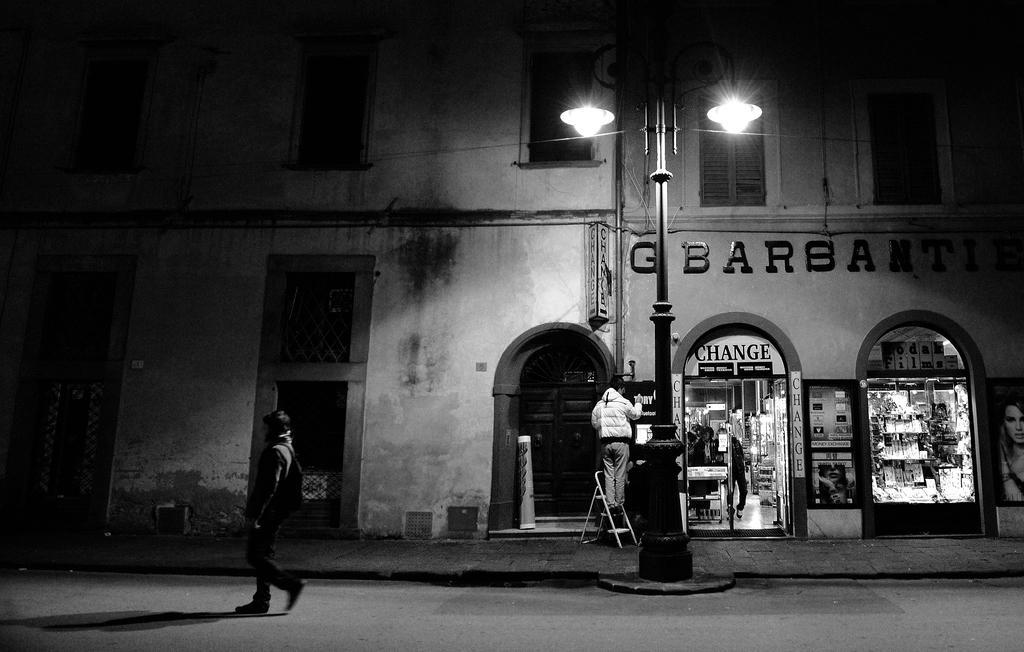Describe this image in one or two sentences. This is a black and white image. In this image we can see a person walking on the road. In the background of the image there is a building. There are windows and doors. There is a store. There is a person standing on a chair. There is a light pole. 